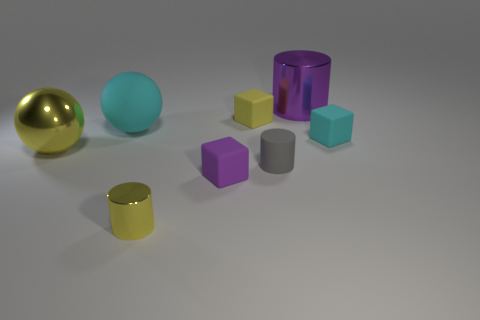What is the color of the small metallic cylinder?
Give a very brief answer. Yellow. Is the purple cylinder made of the same material as the cylinder in front of the small gray rubber thing?
Provide a short and direct response. Yes. How many big objects are both left of the large cyan rubber ball and behind the big metal sphere?
Make the answer very short. 0. What is the shape of the matte object that is the same size as the purple metal cylinder?
Provide a succinct answer. Sphere. Are there any small blocks that are left of the purple object behind the large ball in front of the tiny cyan cube?
Your answer should be compact. Yes. There is a big rubber thing; is its color the same as the small matte cube that is on the right side of the gray cylinder?
Offer a very short reply. Yes. What number of large cylinders are the same color as the small matte cylinder?
Provide a succinct answer. 0. There is a matte object that is right of the metal cylinder behind the yellow cylinder; how big is it?
Offer a very short reply. Small. How many things are either big metallic objects behind the big yellow ball or cubes?
Your response must be concise. 4. Are there any other cyan balls that have the same size as the cyan rubber ball?
Offer a terse response. No. 